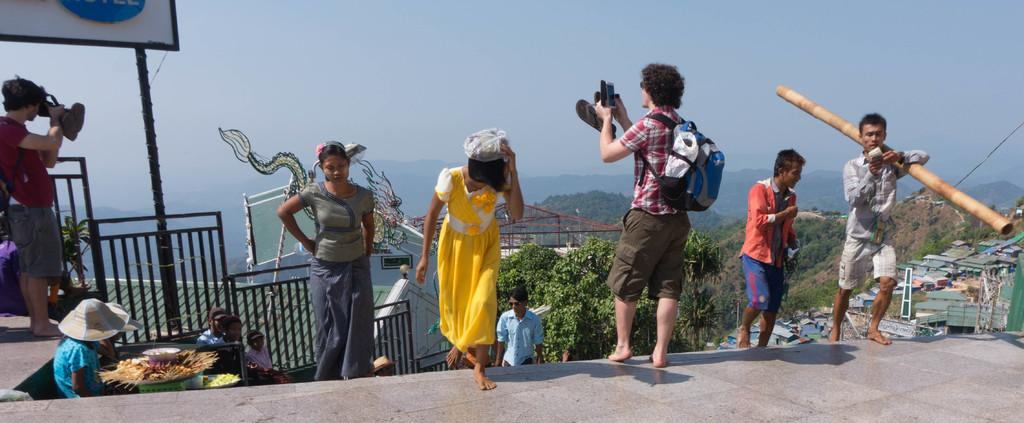What is happening in the foreground of the image? There are persons standing and walking in the foreground of the image. What can be seen in the background of the image? There are houses, trees, sheds, mountains, and a railing in the background of the image. The sky is also visible. How many different types of structures are visible in the background? There are four different types of structures visible in the background: houses, sheds, a railing, and mountains. What type of sink is visible in the image? There is no sink present in the image. How many selections of trees are available in the image? The question is not applicable, as the image does not involve any selections or choices related to trees. 